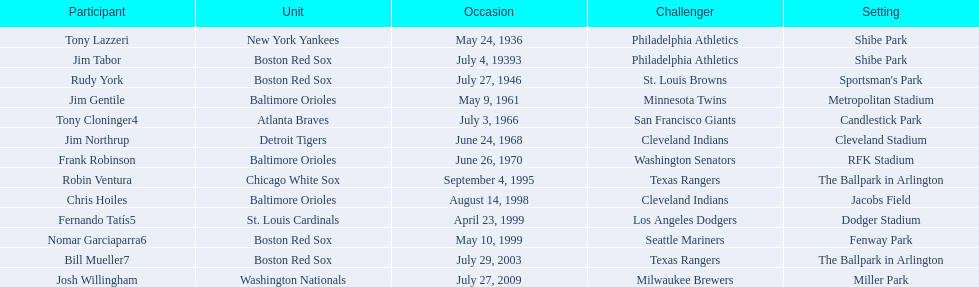Which teams played between the years 1960 and 1970? Baltimore Orioles, Atlanta Braves, Detroit Tigers, Baltimore Orioles. Of these teams that played, which ones played against the cleveland indians? Detroit Tigers. On what day did these two teams play? June 24, 1968. 